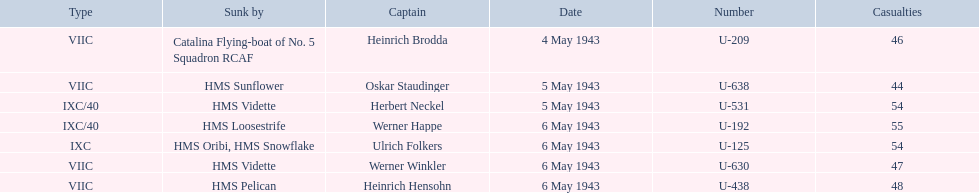Parse the full table. {'header': ['Type', 'Sunk by', 'Captain', 'Date', 'Number', 'Casualties'], 'rows': [['VIIC', 'Catalina Flying-boat of No. 5 Squadron RCAF', 'Heinrich Brodda', '4 May 1943', 'U-209', '46'], ['VIIC', 'HMS Sunflower', 'Oskar Staudinger', '5 May 1943', 'U-638', '44'], ['IXC/40', 'HMS Vidette', 'Herbert Neckel', '5 May 1943', 'U-531', '54'], ['IXC/40', 'HMS Loosestrife', 'Werner Happe', '6 May 1943', 'U-192', '55'], ['IXC', 'HMS Oribi, HMS Snowflake', 'Ulrich Folkers', '6 May 1943', 'U-125', '54'], ['VIIC', 'HMS Vidette', 'Werner Winkler', '6 May 1943', 'U-630', '47'], ['VIIC', 'HMS Pelican', 'Heinrich Hensohn', '6 May 1943', 'U-438', '48']]} Who are the captains of the u boats? Heinrich Brodda, Oskar Staudinger, Herbert Neckel, Werner Happe, Ulrich Folkers, Werner Winkler, Heinrich Hensohn. What are the dates the u boat captains were lost? 4 May 1943, 5 May 1943, 5 May 1943, 6 May 1943, 6 May 1943, 6 May 1943, 6 May 1943. Of these, which were lost on may 5? Oskar Staudinger, Herbert Neckel. Other than oskar staudinger, who else was lost on this day? Herbert Neckel. 